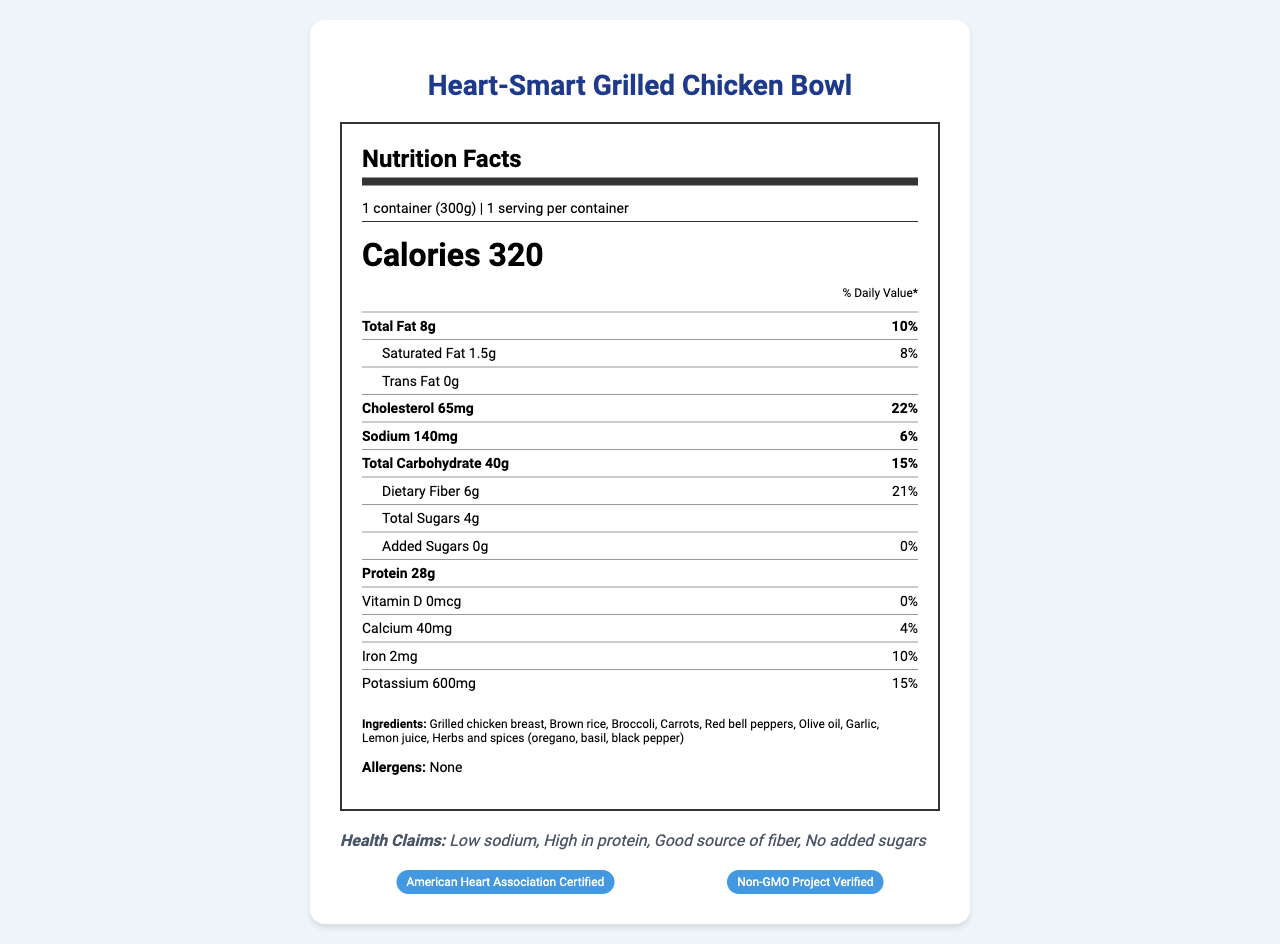how many calories are in one serving? The document states that there are 320 calories per serving.
Answer: 320 what is the serving size of the Heart-Smart Grilled Chicken Bowl? The serving size is listed as "1 container (300g)."
Answer: 1 container (300g) how many grams of total fat does the frozen dinner contain? The nutrition label indicates that the total fat content is 8 grams.
Answer: 8g what percentage of the daily value of dietary fiber does one serving provide? The document shows that the dietary fiber content is 6 grams, which is 21% of the daily value.
Answer: 21% list three main ingredients in the Heart-Smart Grilled Chicken Bowl. The ingredients section lists these three main ingredients among others.
Answer: Grilled chicken breast, Brown rice, Broccoli which of the following certifications does the product have? A. Organic Certified B. American Heart Association Certified C. USDA Certified The certifications section shows that the product is "American Heart Association Certified."
Answer: B what is the total carbohydrate content, and what is its percentage of the daily value? A. 40g, 10% B. 40g, 15% C. 35g, 12% D. 35g, 15% The document states that the total carbohydrate content is 40 grams, which is 15% of the daily value.
Answer: B does the product contain any trans fat? The document states that the trans fat content is 0 grams.
Answer: No does the product contain any allergens? The allergens section lists "None," indicating no allergens are present.
Answer: No summarize the employee wellness benefits provided by this product. The product offers multiple wellness benefits: it supports heart health due to its low sodium content, offers sustained energy with complex carbohydrates, promotes muscle maintenance and recovery with lean protein, supports digestive health with high fiber content, and is convenient for busy professionals.
Answer: Supports heart health, provides sustained energy, promotes muscle maintenance and recovery, supports digestive health, convenient option for busy professionals what is the company’s email address for more information? The contact information section provides the email address "info@healthychoices.com."
Answer: info@healthychoices.com what are the storage instructions for this product? The storage instructions specify to "Keep frozen" and "Cook thoroughly before consuming."
Answer: Keep frozen. Cook thoroughly before consuming. how long should the product be microwaved for? The heating instructions state to microwave the product on high for 4-5 minutes, stirring halfway through.
Answer: 4-5 minutes how many grams of protein does the Heart-Smart Grilled Chicken Bowl contain? The nutrition label indicates the protein content as 28 grams.
Answer: 28g what are the health claims made about this product? A. Supports weight loss B. Low sodium C. High in protein D. High in sugar E. Good source of fiber The health claims listed are "Low sodium," "High in protein," and "Good source of fiber."
Answer: B, C, E how is this product suitable for heart health? The employee wellness benefits section states that the product supports heart health due to its low sodium content.
Answer: Supports heart health with low sodium content what is the manufacturer's name? The document lists the manufacturer as "Healthy Choices, Inc."
Answer: Healthy Choices, Inc. which vitamins and minerals are listed with their daily value percentages? The nutrients with daily value percentages listed are Calcium (4%), Iron (10%), and Potassium (15%).
Answer: Calcium, Iron, Potassium is this product gluten-free? The document does not specify whether the product is gluten-free.
Answer: Not enough information what is the main idea of this document? The document describes the product, emphasizing its nutritional content, ingredients, health-related certifications, and benefits for health-conscious employees.
Answer: The document provides nutritional information, ingredients, health claims, and employee wellness benefits for the "Heart-Smart Grilled Chicken Bowl," a low-sodium, heart-healthy frozen dinner option. 